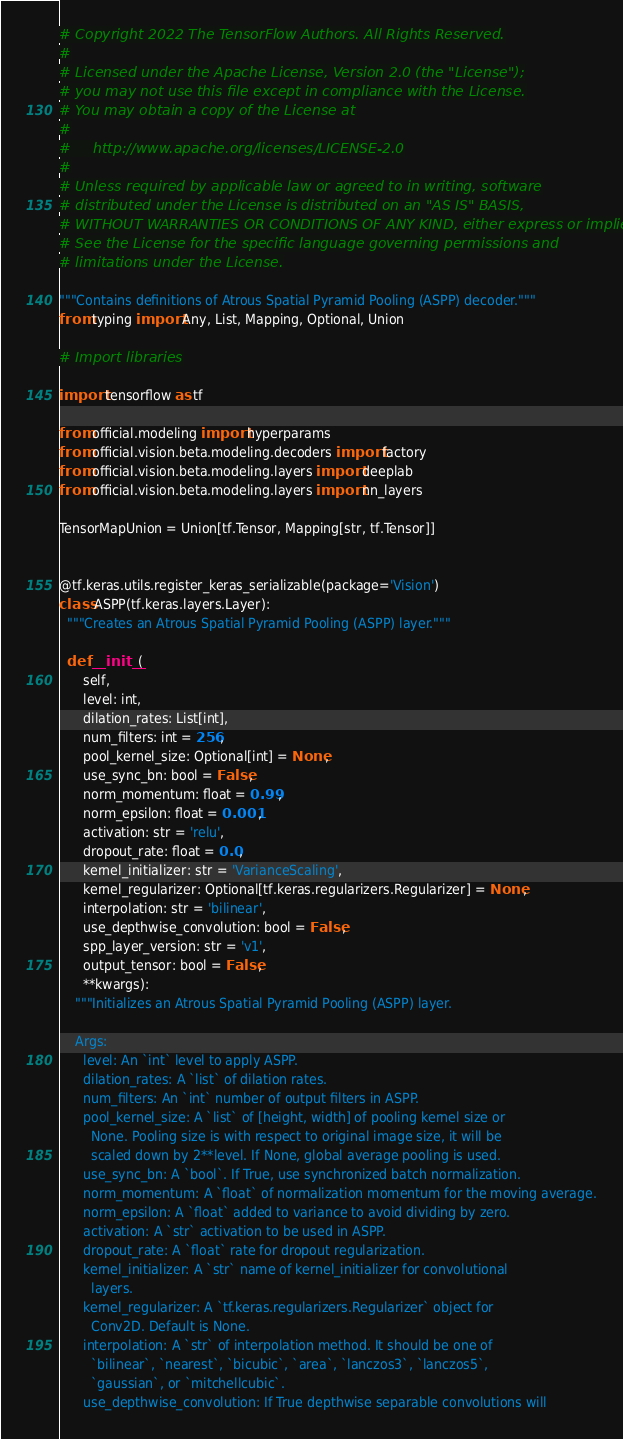Convert code to text. <code><loc_0><loc_0><loc_500><loc_500><_Python_># Copyright 2022 The TensorFlow Authors. All Rights Reserved.
#
# Licensed under the Apache License, Version 2.0 (the "License");
# you may not use this file except in compliance with the License.
# You may obtain a copy of the License at
#
#     http://www.apache.org/licenses/LICENSE-2.0
#
# Unless required by applicable law or agreed to in writing, software
# distributed under the License is distributed on an "AS IS" BASIS,
# WITHOUT WARRANTIES OR CONDITIONS OF ANY KIND, either express or implied.
# See the License for the specific language governing permissions and
# limitations under the License.

"""Contains definitions of Atrous Spatial Pyramid Pooling (ASPP) decoder."""
from typing import Any, List, Mapping, Optional, Union

# Import libraries

import tensorflow as tf

from official.modeling import hyperparams
from official.vision.beta.modeling.decoders import factory
from official.vision.beta.modeling.layers import deeplab
from official.vision.beta.modeling.layers import nn_layers

TensorMapUnion = Union[tf.Tensor, Mapping[str, tf.Tensor]]


@tf.keras.utils.register_keras_serializable(package='Vision')
class ASPP(tf.keras.layers.Layer):
  """Creates an Atrous Spatial Pyramid Pooling (ASPP) layer."""

  def __init__(
      self,
      level: int,
      dilation_rates: List[int],
      num_filters: int = 256,
      pool_kernel_size: Optional[int] = None,
      use_sync_bn: bool = False,
      norm_momentum: float = 0.99,
      norm_epsilon: float = 0.001,
      activation: str = 'relu',
      dropout_rate: float = 0.0,
      kernel_initializer: str = 'VarianceScaling',
      kernel_regularizer: Optional[tf.keras.regularizers.Regularizer] = None,
      interpolation: str = 'bilinear',
      use_depthwise_convolution: bool = False,
      spp_layer_version: str = 'v1',
      output_tensor: bool = False,
      **kwargs):
    """Initializes an Atrous Spatial Pyramid Pooling (ASPP) layer.

    Args:
      level: An `int` level to apply ASPP.
      dilation_rates: A `list` of dilation rates.
      num_filters: An `int` number of output filters in ASPP.
      pool_kernel_size: A `list` of [height, width] of pooling kernel size or
        None. Pooling size is with respect to original image size, it will be
        scaled down by 2**level. If None, global average pooling is used.
      use_sync_bn: A `bool`. If True, use synchronized batch normalization.
      norm_momentum: A `float` of normalization momentum for the moving average.
      norm_epsilon: A `float` added to variance to avoid dividing by zero.
      activation: A `str` activation to be used in ASPP.
      dropout_rate: A `float` rate for dropout regularization.
      kernel_initializer: A `str` name of kernel_initializer for convolutional
        layers.
      kernel_regularizer: A `tf.keras.regularizers.Regularizer` object for
        Conv2D. Default is None.
      interpolation: A `str` of interpolation method. It should be one of
        `bilinear`, `nearest`, `bicubic`, `area`, `lanczos3`, `lanczos5`,
        `gaussian`, or `mitchellcubic`.
      use_depthwise_convolution: If True depthwise separable convolutions will</code> 